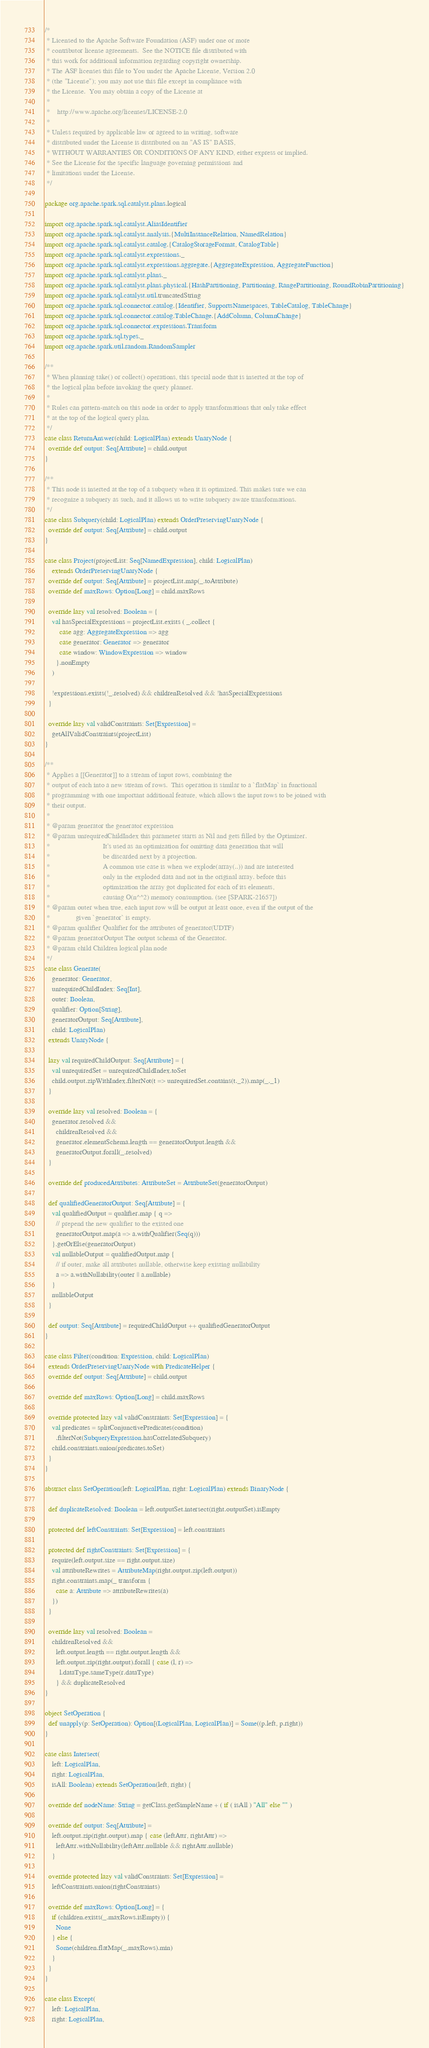Convert code to text. <code><loc_0><loc_0><loc_500><loc_500><_Scala_>/*
 * Licensed to the Apache Software Foundation (ASF) under one or more
 * contributor license agreements.  See the NOTICE file distributed with
 * this work for additional information regarding copyright ownership.
 * The ASF licenses this file to You under the Apache License, Version 2.0
 * (the "License"); you may not use this file except in compliance with
 * the License.  You may obtain a copy of the License at
 *
 *    http://www.apache.org/licenses/LICENSE-2.0
 *
 * Unless required by applicable law or agreed to in writing, software
 * distributed under the License is distributed on an "AS IS" BASIS,
 * WITHOUT WARRANTIES OR CONDITIONS OF ANY KIND, either express or implied.
 * See the License for the specific language governing permissions and
 * limitations under the License.
 */

package org.apache.spark.sql.catalyst.plans.logical

import org.apache.spark.sql.catalyst.AliasIdentifier
import org.apache.spark.sql.catalyst.analysis.{MultiInstanceRelation, NamedRelation}
import org.apache.spark.sql.catalyst.catalog.{CatalogStorageFormat, CatalogTable}
import org.apache.spark.sql.catalyst.expressions._
import org.apache.spark.sql.catalyst.expressions.aggregate.{AggregateExpression, AggregateFunction}
import org.apache.spark.sql.catalyst.plans._
import org.apache.spark.sql.catalyst.plans.physical.{HashPartitioning, Partitioning, RangePartitioning, RoundRobinPartitioning}
import org.apache.spark.sql.catalyst.util.truncatedString
import org.apache.spark.sql.connector.catalog.{Identifier, SupportsNamespaces, TableCatalog, TableChange}
import org.apache.spark.sql.connector.catalog.TableChange.{AddColumn, ColumnChange}
import org.apache.spark.sql.connector.expressions.Transform
import org.apache.spark.sql.types._
import org.apache.spark.util.random.RandomSampler

/**
 * When planning take() or collect() operations, this special node that is inserted at the top of
 * the logical plan before invoking the query planner.
 *
 * Rules can pattern-match on this node in order to apply transformations that only take effect
 * at the top of the logical query plan.
 */
case class ReturnAnswer(child: LogicalPlan) extends UnaryNode {
  override def output: Seq[Attribute] = child.output
}

/**
 * This node is inserted at the top of a subquery when it is optimized. This makes sure we can
 * recognize a subquery as such, and it allows us to write subquery aware transformations.
 */
case class Subquery(child: LogicalPlan) extends OrderPreservingUnaryNode {
  override def output: Seq[Attribute] = child.output
}

case class Project(projectList: Seq[NamedExpression], child: LogicalPlan)
    extends OrderPreservingUnaryNode {
  override def output: Seq[Attribute] = projectList.map(_.toAttribute)
  override def maxRows: Option[Long] = child.maxRows

  override lazy val resolved: Boolean = {
    val hasSpecialExpressions = projectList.exists ( _.collect {
        case agg: AggregateExpression => agg
        case generator: Generator => generator
        case window: WindowExpression => window
      }.nonEmpty
    )

    !expressions.exists(!_.resolved) && childrenResolved && !hasSpecialExpressions
  }

  override lazy val validConstraints: Set[Expression] =
    getAllValidConstraints(projectList)
}

/**
 * Applies a [[Generator]] to a stream of input rows, combining the
 * output of each into a new stream of rows.  This operation is similar to a `flatMap` in functional
 * programming with one important additional feature, which allows the input rows to be joined with
 * their output.
 *
 * @param generator the generator expression
 * @param unrequiredChildIndex this parameter starts as Nil and gets filled by the Optimizer.
 *                             It's used as an optimization for omitting data generation that will
 *                             be discarded next by a projection.
 *                             A common use case is when we explode(array(..)) and are interested
 *                             only in the exploded data and not in the original array. before this
 *                             optimization the array got duplicated for each of its elements,
 *                             causing O(n^^2) memory consumption. (see [SPARK-21657])
 * @param outer when true, each input row will be output at least once, even if the output of the
 *              given `generator` is empty.
 * @param qualifier Qualifier for the attributes of generator(UDTF)
 * @param generatorOutput The output schema of the Generator.
 * @param child Children logical plan node
 */
case class Generate(
    generator: Generator,
    unrequiredChildIndex: Seq[Int],
    outer: Boolean,
    qualifier: Option[String],
    generatorOutput: Seq[Attribute],
    child: LogicalPlan)
  extends UnaryNode {

  lazy val requiredChildOutput: Seq[Attribute] = {
    val unrequiredSet = unrequiredChildIndex.toSet
    child.output.zipWithIndex.filterNot(t => unrequiredSet.contains(t._2)).map(_._1)
  }

  override lazy val resolved: Boolean = {
    generator.resolved &&
      childrenResolved &&
      generator.elementSchema.length == generatorOutput.length &&
      generatorOutput.forall(_.resolved)
  }

  override def producedAttributes: AttributeSet = AttributeSet(generatorOutput)

  def qualifiedGeneratorOutput: Seq[Attribute] = {
    val qualifiedOutput = qualifier.map { q =>
      // prepend the new qualifier to the existed one
      generatorOutput.map(a => a.withQualifier(Seq(q)))
    }.getOrElse(generatorOutput)
    val nullableOutput = qualifiedOutput.map {
      // if outer, make all attributes nullable, otherwise keep existing nullability
      a => a.withNullability(outer || a.nullable)
    }
    nullableOutput
  }

  def output: Seq[Attribute] = requiredChildOutput ++ qualifiedGeneratorOutput
}

case class Filter(condition: Expression, child: LogicalPlan)
  extends OrderPreservingUnaryNode with PredicateHelper {
  override def output: Seq[Attribute] = child.output

  override def maxRows: Option[Long] = child.maxRows

  override protected lazy val validConstraints: Set[Expression] = {
    val predicates = splitConjunctivePredicates(condition)
      .filterNot(SubqueryExpression.hasCorrelatedSubquery)
    child.constraints.union(predicates.toSet)
  }
}

abstract class SetOperation(left: LogicalPlan, right: LogicalPlan) extends BinaryNode {

  def duplicateResolved: Boolean = left.outputSet.intersect(right.outputSet).isEmpty

  protected def leftConstraints: Set[Expression] = left.constraints

  protected def rightConstraints: Set[Expression] = {
    require(left.output.size == right.output.size)
    val attributeRewrites = AttributeMap(right.output.zip(left.output))
    right.constraints.map(_ transform {
      case a: Attribute => attributeRewrites(a)
    })
  }

  override lazy val resolved: Boolean =
    childrenResolved &&
      left.output.length == right.output.length &&
      left.output.zip(right.output).forall { case (l, r) =>
        l.dataType.sameType(r.dataType)
      } && duplicateResolved
}

object SetOperation {
  def unapply(p: SetOperation): Option[(LogicalPlan, LogicalPlan)] = Some((p.left, p.right))
}

case class Intersect(
    left: LogicalPlan,
    right: LogicalPlan,
    isAll: Boolean) extends SetOperation(left, right) {

  override def nodeName: String = getClass.getSimpleName + ( if ( isAll ) "All" else "" )

  override def output: Seq[Attribute] =
    left.output.zip(right.output).map { case (leftAttr, rightAttr) =>
      leftAttr.withNullability(leftAttr.nullable && rightAttr.nullable)
    }

  override protected lazy val validConstraints: Set[Expression] =
    leftConstraints.union(rightConstraints)

  override def maxRows: Option[Long] = {
    if (children.exists(_.maxRows.isEmpty)) {
      None
    } else {
      Some(children.flatMap(_.maxRows).min)
    }
  }
}

case class Except(
    left: LogicalPlan,
    right: LogicalPlan,</code> 